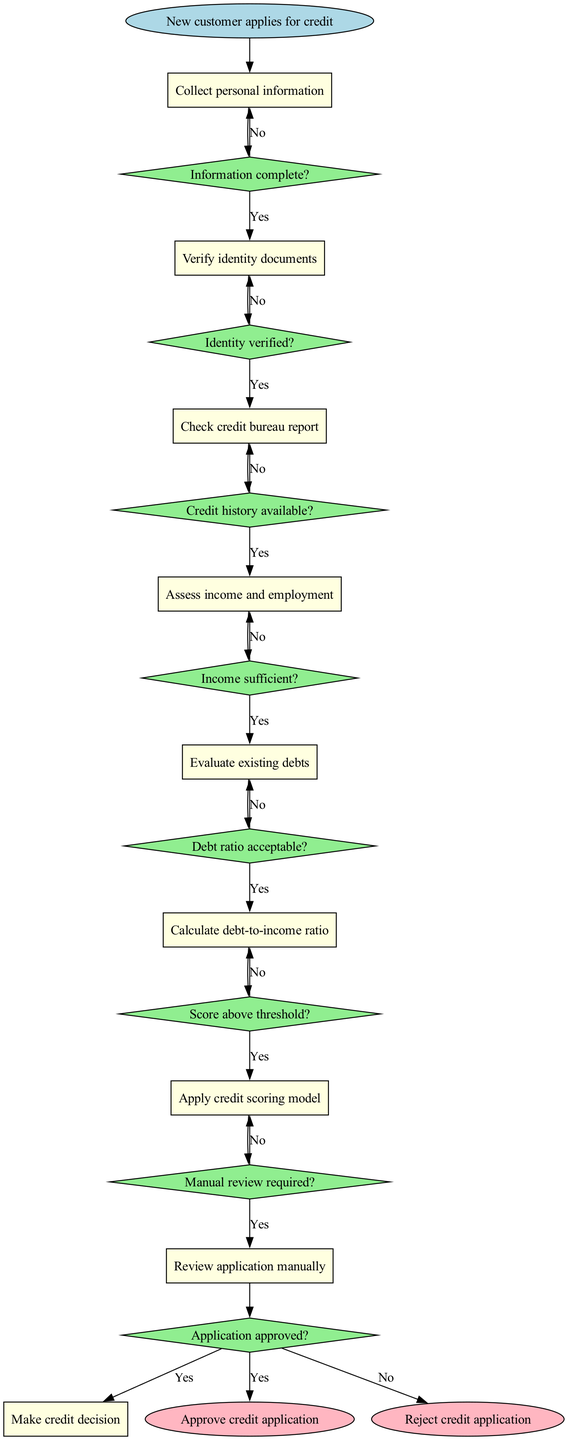What is the first step in the credit application process? The diagram indicates that the first step is represented by the "start" node, which states, "New customer applies for credit."
Answer: New customer applies for credit How many nodes are present in the diagram? The diagram consists of 9 nodes, including the start and end nodes, as identified through the structure of the flowchart.
Answer: 9 What decision follows verifying identity documents? After verifying identity documents, the next decision in the flowchart is represented by the edge leading to the decision node labeled "Credit history available?"
Answer: Credit history available? What happens if the debt ratio is not acceptable? If the debt ratio is not acceptable, the flowchart shows that the process loops back to the "Evaluate existing debts" node, indicating a manual review or further checks will occur.
Answer: Evaluate existing debts How many edges connect the decision nodes in the diagram? Each decision node has edges connected to the subsequent nodes and back to the prior node for "No" responses, leading to a total of 8 edges connecting the decision nodes.
Answer: 8 What is the outcome if the score is above the threshold? If the score is above the threshold, the flowchart designates that the application will be approved, as indicated by the edge leading to the end node labeled "Approve credit application."
Answer: Approve credit application What document verification process is required? The diagram specifies that the required verification process is "Verify identity documents," which is a crucial step before checking the credit report.
Answer: Verify identity documents What will be reviewed manually after the application analysis? The flowchart indicates that the "Review application manually" decision occurs subsequent to applying the credit scoring model, indicating a step for further assessment.
Answer: Review application manually What leads to the rejection of a credit application? The rejection occurs if the final decision at the last node indicates "No" when determining if the score is above the threshold, as shown in the flowchart process.
Answer: Score below threshold 